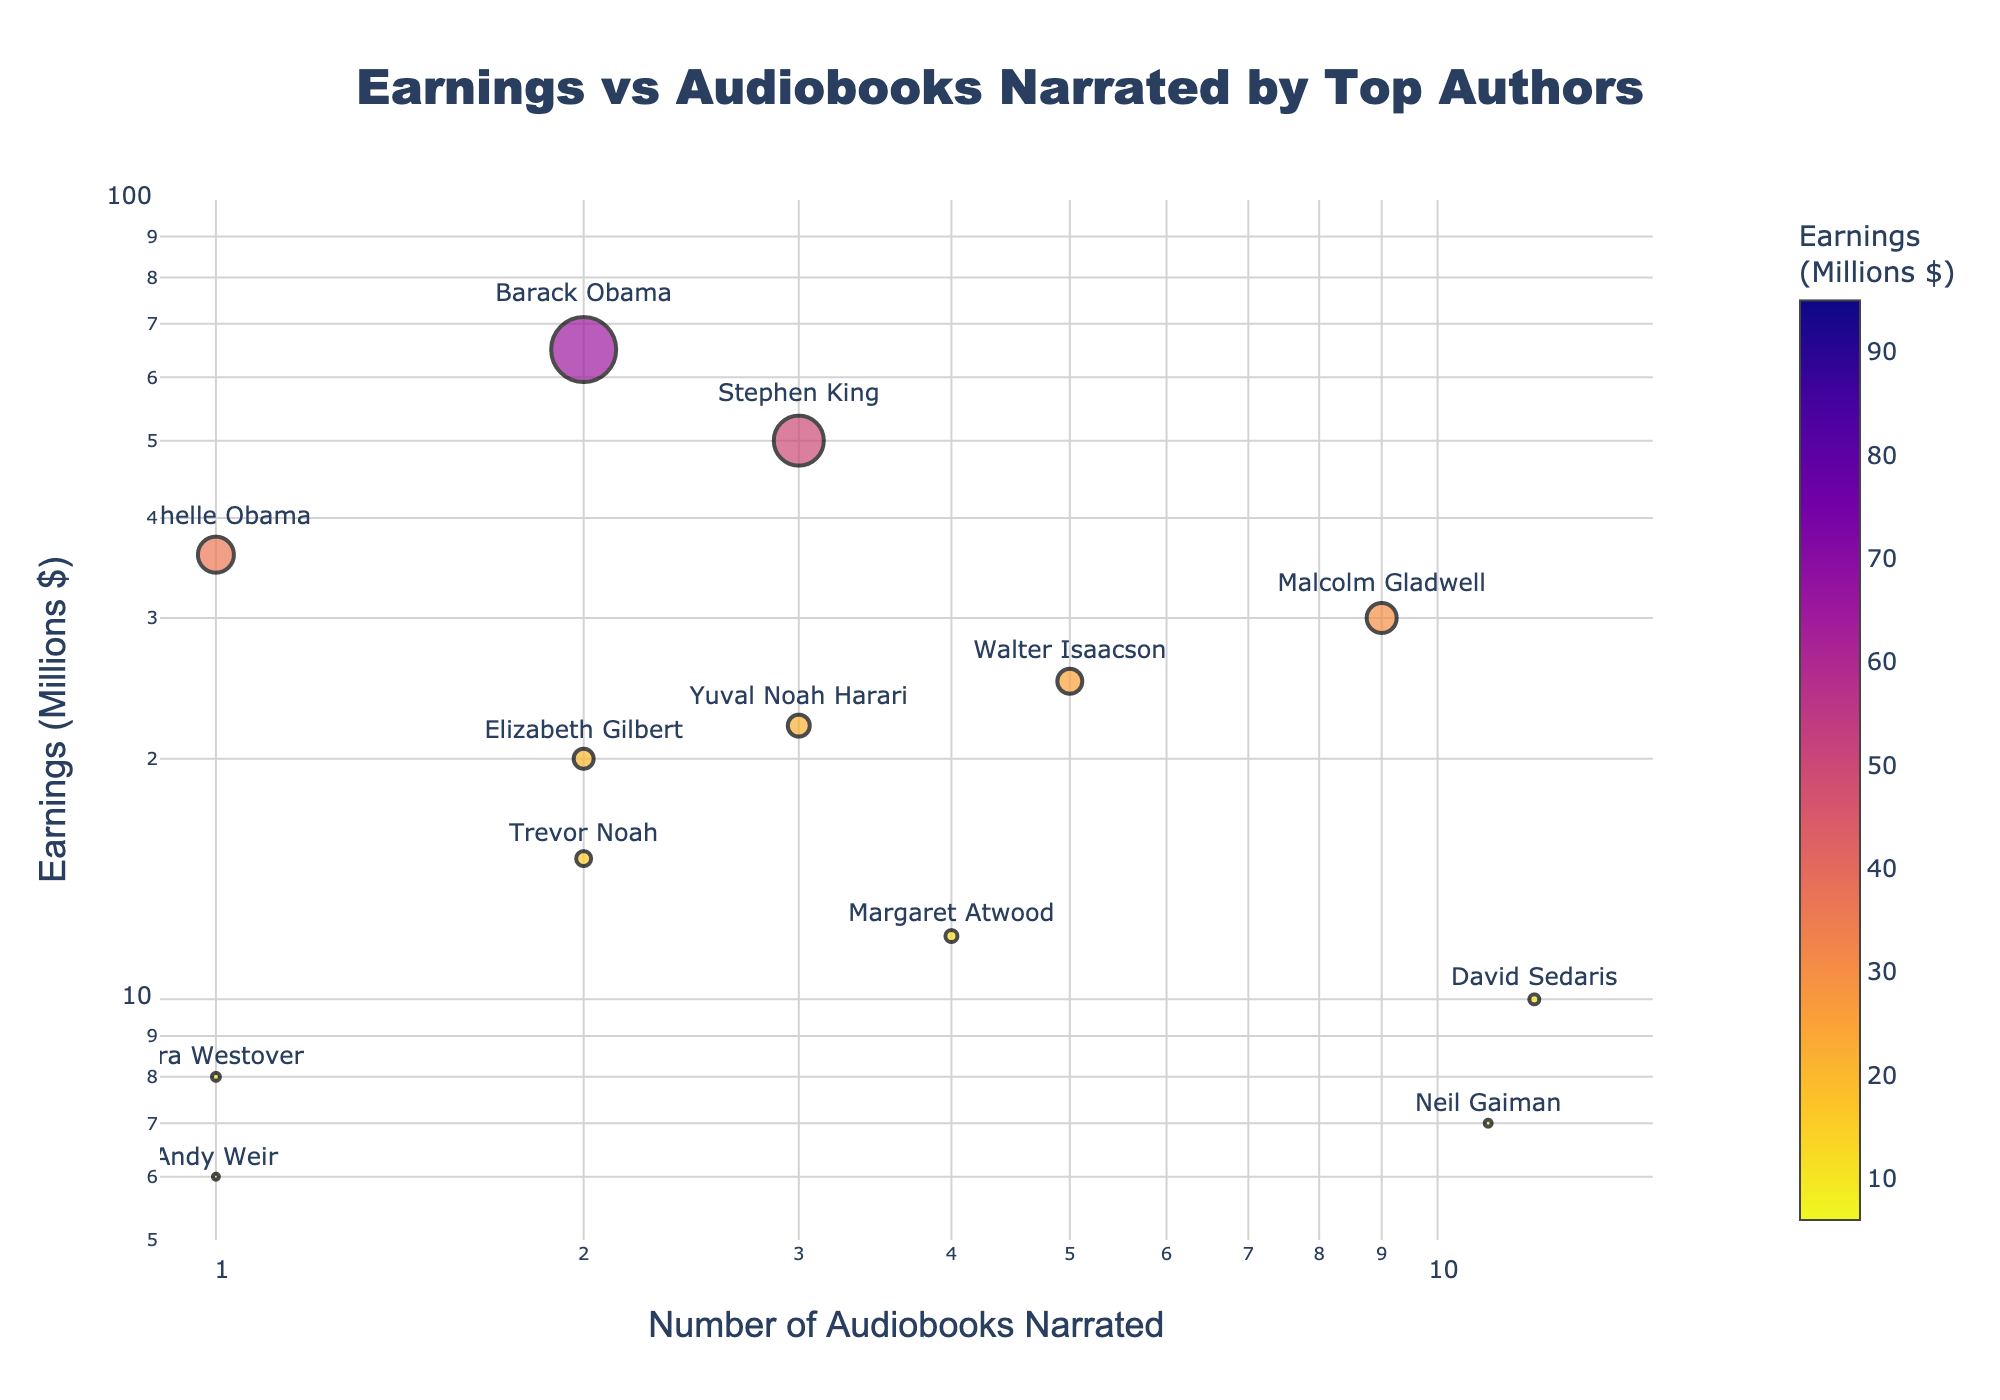What's the title of the figure? The title is displayed clearly at the top of the figure.
Answer: Earnings vs Audiobooks Narrated by Top Authors How many audiobooks has Neil Gaiman narrated? Neil Gaiman's name is highlighted next to a data point on the x-axis, which represents audiobooks narrated.
Answer: 11 Which author has the highest earnings and how many audiobooks have they narrated? By hovering over data points or observing the largest marker, you find J.K. Rowling has the highest earnings and has narrated 0 audiobooks.
Answer: J.K. Rowling, 0 Who has narrated the most audiobooks and what are their earnings? By finding the data point that is farthest to the right on the x-axis and hovering over it, we see David Sedaris has narrated the most with 12 audiobooks and earned $10 million.
Answer: David Sedaris, $10M What is the range of earnings shown on the y-axis? Examining the y-axis, the lowest value begins slightly above 5, and the highest value is slightly below 100 million dollars.
Answer: $5M to $100M How many authors have narrated exactly 1 audiobook? By checking the data points with x-axis value 1 and identifying the corresponding authors, we see there are 4 authors (Michelle Obama, Andy Weir, and Tara Westover).
Answer: 3 Who has narrated the same number of audiobooks as Stephen King and what are their earnings? Stephen King has narrated 3 audiobooks. By checking the data points at x = 3, we find Yuval Noah Harari has also narrated 3 audiobooks, earning $22 million.
Answer: Yuval Noah Harari, $22M Compare the earnings of Barack Obama and Trevor Noah. Who earns more and by how much? Barack Obama earned $65 million and Trevor Noah $15 million. The difference in their earnings is $65M - $15M = $50M.
Answer: Barack Obama, $50M What is the trend between the number of audiobooks narrated and the earnings? Observing the scatter plot, there is no clear correlation between the number of audiobooks narrated and the earnings as authors with high earnings can have 0 to several audiobooks narrated.
Answer: No clear trend 